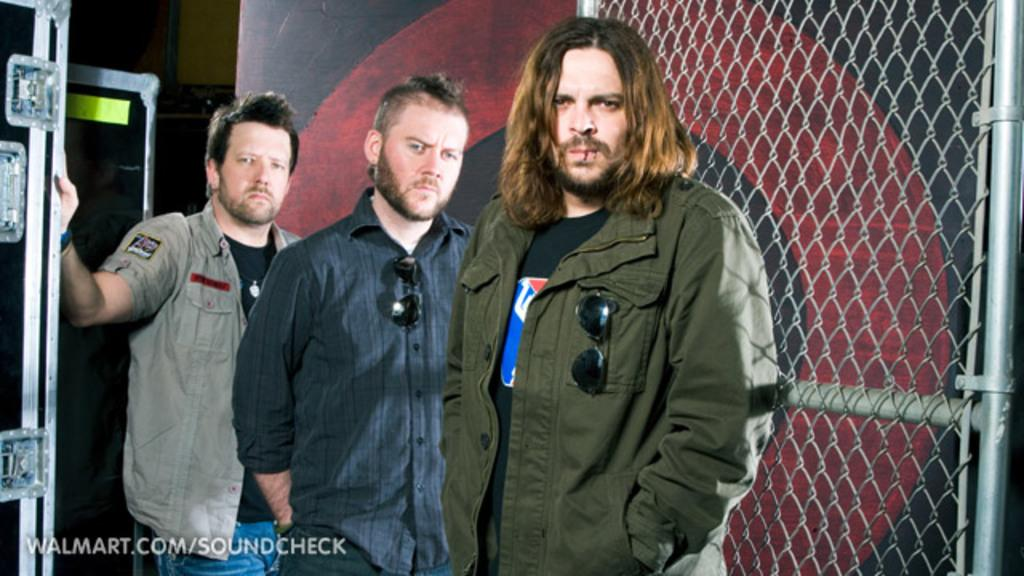How many people are in the image? There are three persons visible in the image. What is the background of the image? The persons are in front of a fence. Where is the door located in the image? There is a door on the left side of the image. What can be found at the bottom of the image? There is text visible at the bottom of the image. What is the opinion of the toe in the image? There is no toe present in the image, so it is not possible to determine its opinion. 